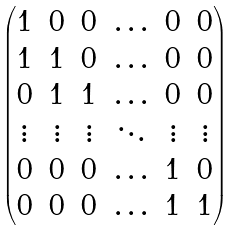<formula> <loc_0><loc_0><loc_500><loc_500>\begin{pmatrix} 1 & 0 & 0 & \hdots & 0 & 0 \\ 1 & 1 & 0 & \hdots & 0 & 0 \\ 0 & 1 & 1 & \hdots & 0 & 0 \\ \vdots & \vdots & \vdots & \ddots & \vdots & \vdots \\ 0 & 0 & 0 & \hdots & 1 & 0 \\ 0 & 0 & 0 & \hdots & 1 & 1 \\ \end{pmatrix}</formula> 